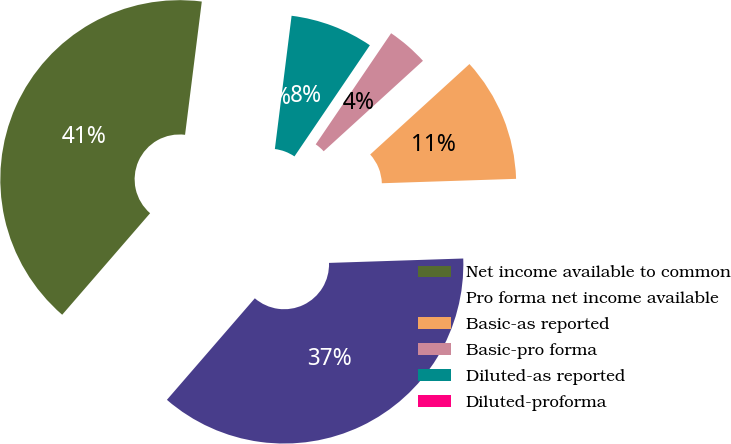Convert chart to OTSL. <chart><loc_0><loc_0><loc_500><loc_500><pie_chart><fcel>Net income available to common<fcel>Pro forma net income available<fcel>Basic-as reported<fcel>Basic-pro forma<fcel>Diluted-as reported<fcel>Diluted-proforma<nl><fcel>40.63%<fcel>36.88%<fcel>11.24%<fcel>3.75%<fcel>7.5%<fcel>0.0%<nl></chart> 